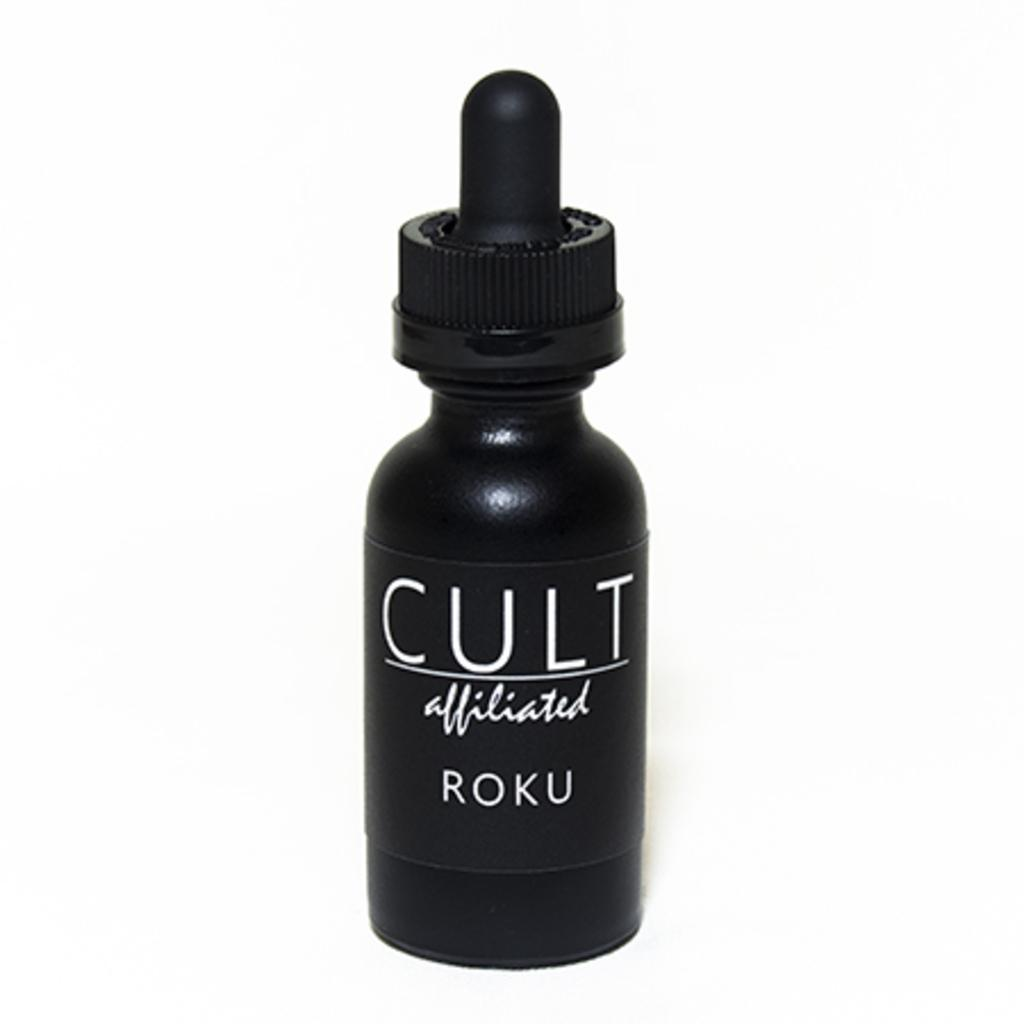<image>
Present a compact description of the photo's key features. the bottle of cult affiliated ROKU is black with a dropper top 